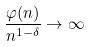Convert formula to latex. <formula><loc_0><loc_0><loc_500><loc_500>\frac { \varphi ( n ) } { n ^ { 1 - \delta } } \rightarrow \infty</formula> 